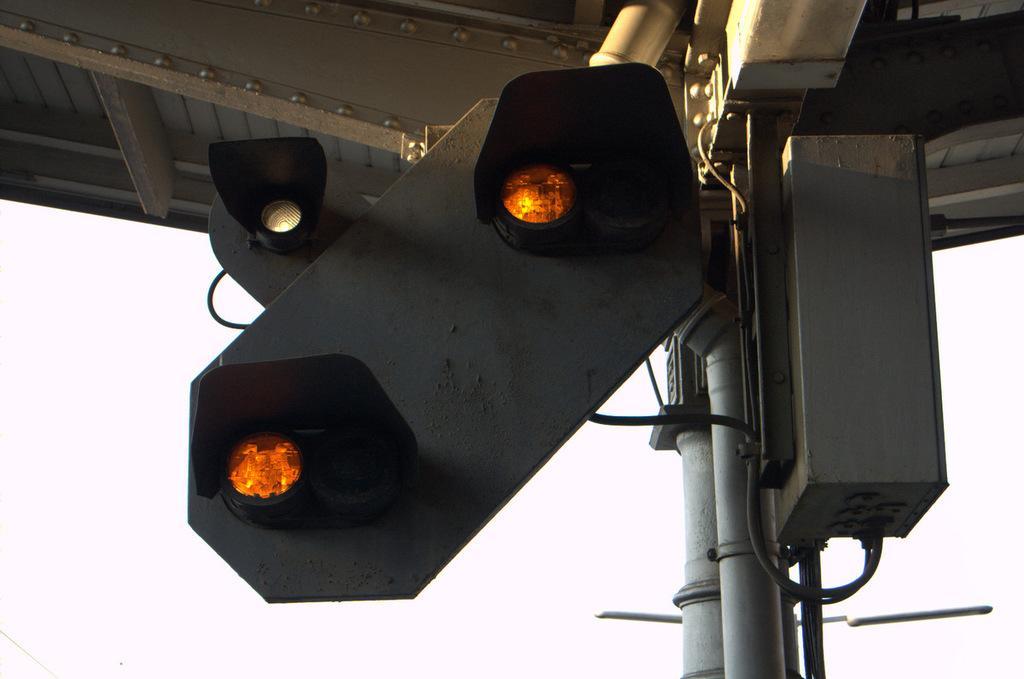Describe this image in one or two sentences. There are signal lights attached to the poles. Above these, there is a roof. The background is white in color. 